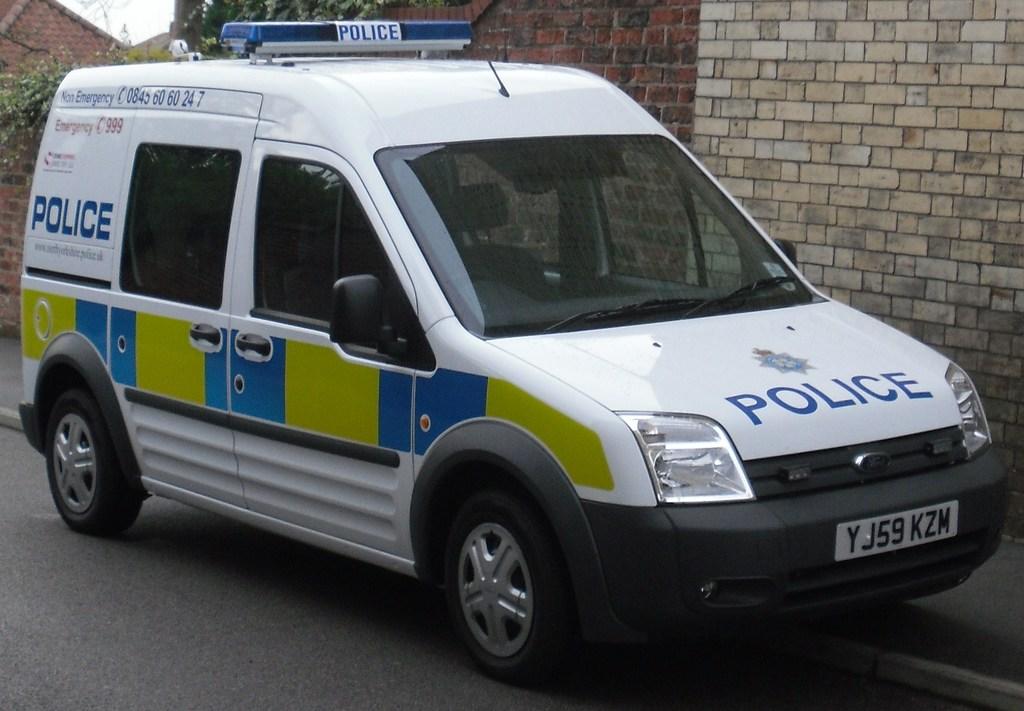What department is this vehicle part of?
Offer a terse response. Police. What is the licence plate number?
Offer a terse response. Yj59kzm. 